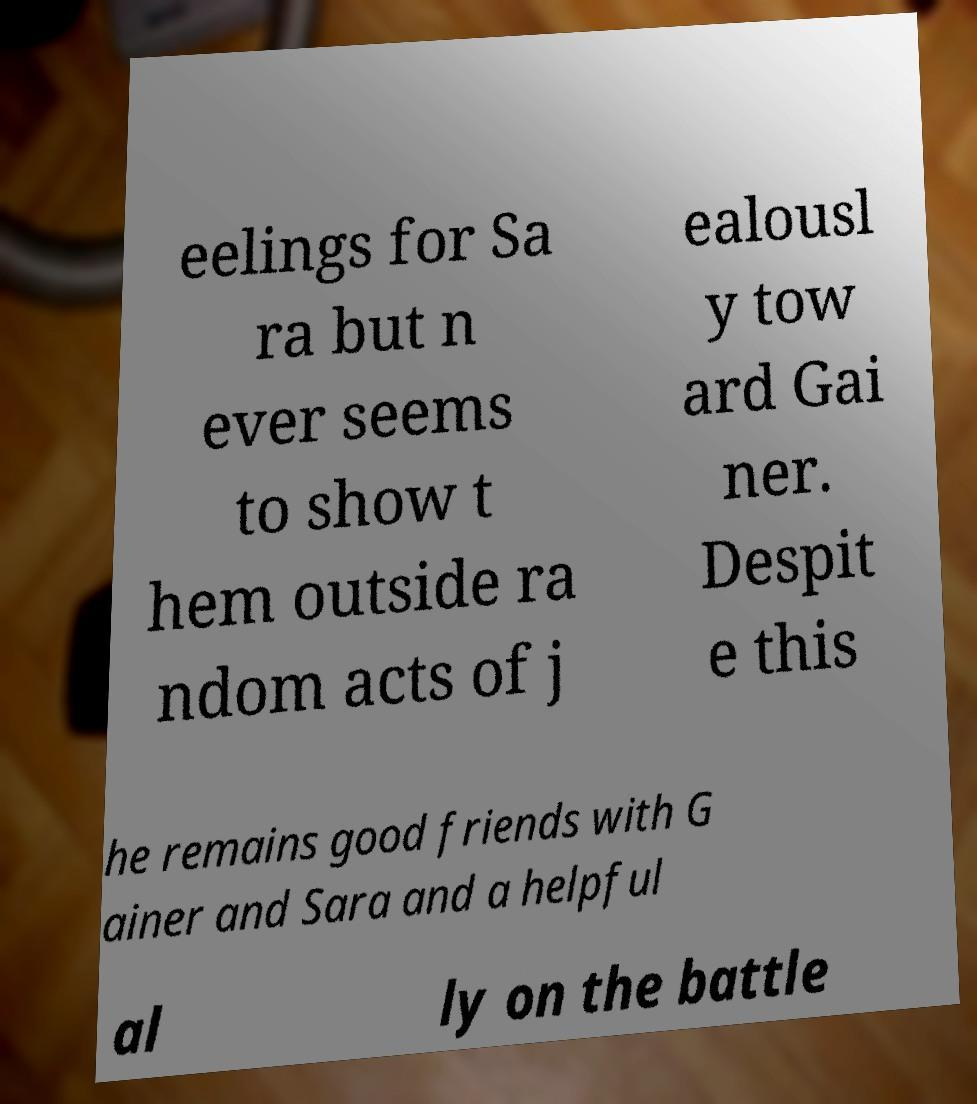Can you accurately transcribe the text from the provided image for me? eelings for Sa ra but n ever seems to show t hem outside ra ndom acts of j ealousl y tow ard Gai ner. Despit e this he remains good friends with G ainer and Sara and a helpful al ly on the battle 